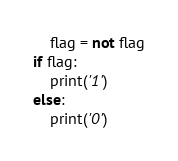Convert code to text. <code><loc_0><loc_0><loc_500><loc_500><_Python_>    flag = not flag
if flag:
    print('1') 
else:
    print('0')   
</code> 